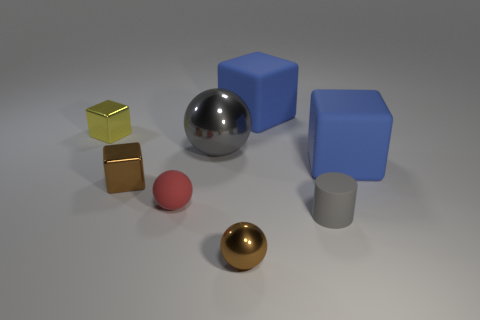Are there more small gray objects that are in front of the tiny yellow metal cube than small yellow spheres?
Keep it short and to the point. Yes. There is a gray cylinder right of the red matte object; what is its material?
Your answer should be compact. Rubber. What number of red things are the same material as the cylinder?
Your answer should be very brief. 1. What shape is the object that is both behind the small brown ball and in front of the matte ball?
Make the answer very short. Cylinder. How many things are tiny gray rubber cylinders behind the small brown sphere or things that are behind the tiny gray rubber object?
Provide a succinct answer. 7. Are there the same number of gray metal spheres that are on the right side of the tiny red rubber sphere and tiny rubber objects that are to the left of the tiny metallic ball?
Provide a succinct answer. Yes. The gray thing right of the metal thing in front of the small red ball is what shape?
Ensure brevity in your answer.  Cylinder. Are there any gray things of the same shape as the tiny red object?
Give a very brief answer. Yes. What number of tiny metal balls are there?
Ensure brevity in your answer.  1. Are the small brown thing in front of the tiny red object and the tiny cylinder made of the same material?
Your answer should be very brief. No. 